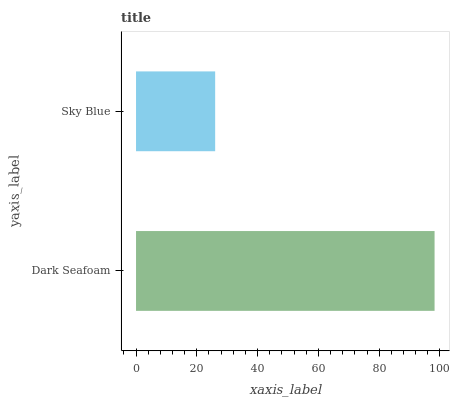Is Sky Blue the minimum?
Answer yes or no. Yes. Is Dark Seafoam the maximum?
Answer yes or no. Yes. Is Sky Blue the maximum?
Answer yes or no. No. Is Dark Seafoam greater than Sky Blue?
Answer yes or no. Yes. Is Sky Blue less than Dark Seafoam?
Answer yes or no. Yes. Is Sky Blue greater than Dark Seafoam?
Answer yes or no. No. Is Dark Seafoam less than Sky Blue?
Answer yes or no. No. Is Dark Seafoam the high median?
Answer yes or no. Yes. Is Sky Blue the low median?
Answer yes or no. Yes. Is Sky Blue the high median?
Answer yes or no. No. Is Dark Seafoam the low median?
Answer yes or no. No. 